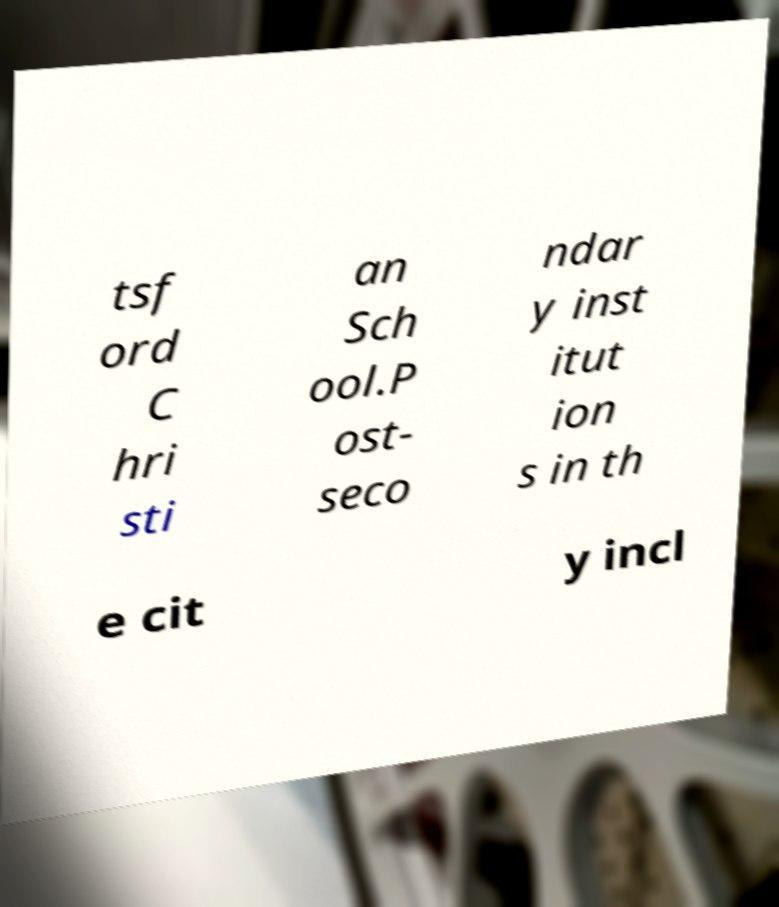Can you accurately transcribe the text from the provided image for me? tsf ord C hri sti an Sch ool.P ost- seco ndar y inst itut ion s in th e cit y incl 